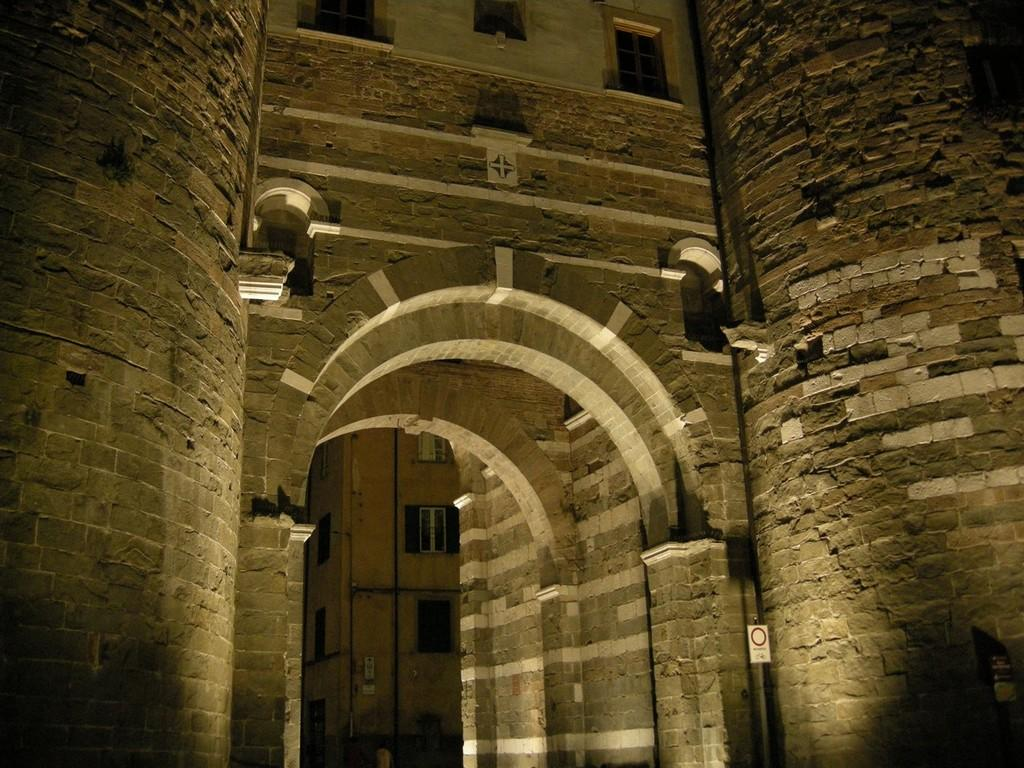What type of architectural feature can be seen in the image? There are arches in the image. What other objects are present in the image? There are pipes and buildings with windows in the image. How many knees are visible in the image? There are no knees present in the image. Who is the representative in the image? There is no representative depicted in the image. 